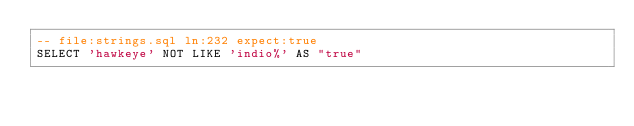<code> <loc_0><loc_0><loc_500><loc_500><_SQL_>-- file:strings.sql ln:232 expect:true
SELECT 'hawkeye' NOT LIKE 'indio%' AS "true"
</code> 